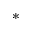Convert formula to latex. <formula><loc_0><loc_0><loc_500><loc_500>\ast</formula> 